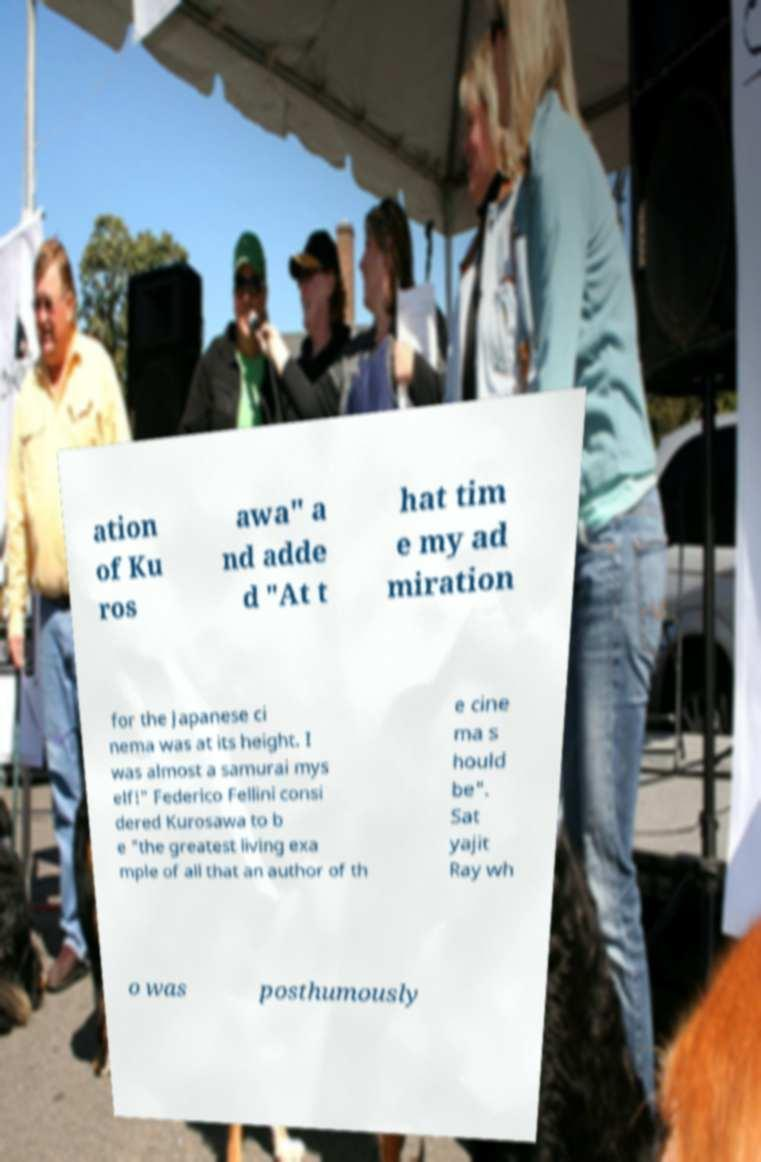I need the written content from this picture converted into text. Can you do that? ation of Ku ros awa" a nd adde d "At t hat tim e my ad miration for the Japanese ci nema was at its height. I was almost a samurai mys elf!" Federico Fellini consi dered Kurosawa to b e "the greatest living exa mple of all that an author of th e cine ma s hould be". Sat yajit Ray wh o was posthumously 